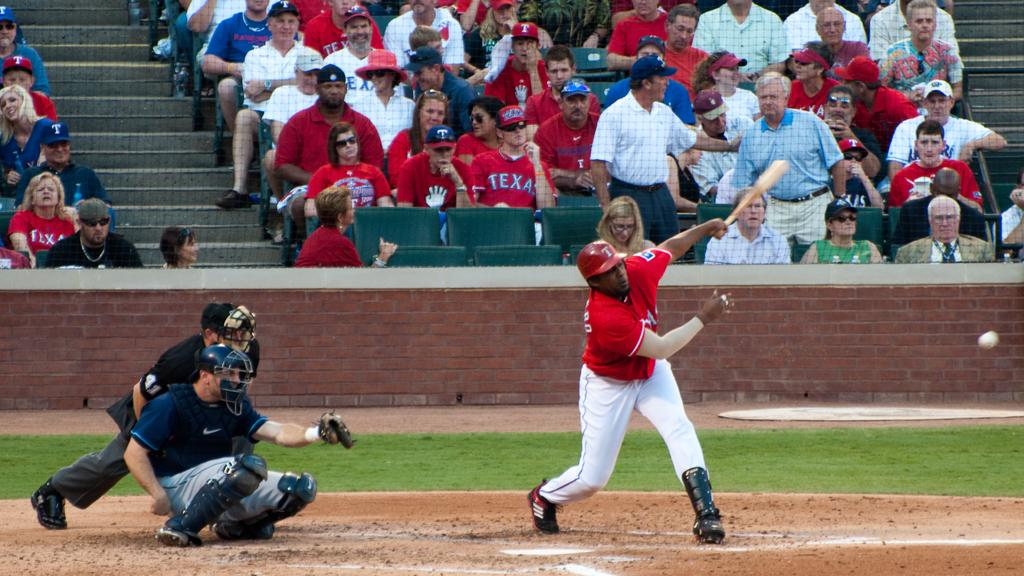<image>
Relay a brief, clear account of the picture shown. Several people in the crowd at a baseball game are wearing red Texas shirts. 